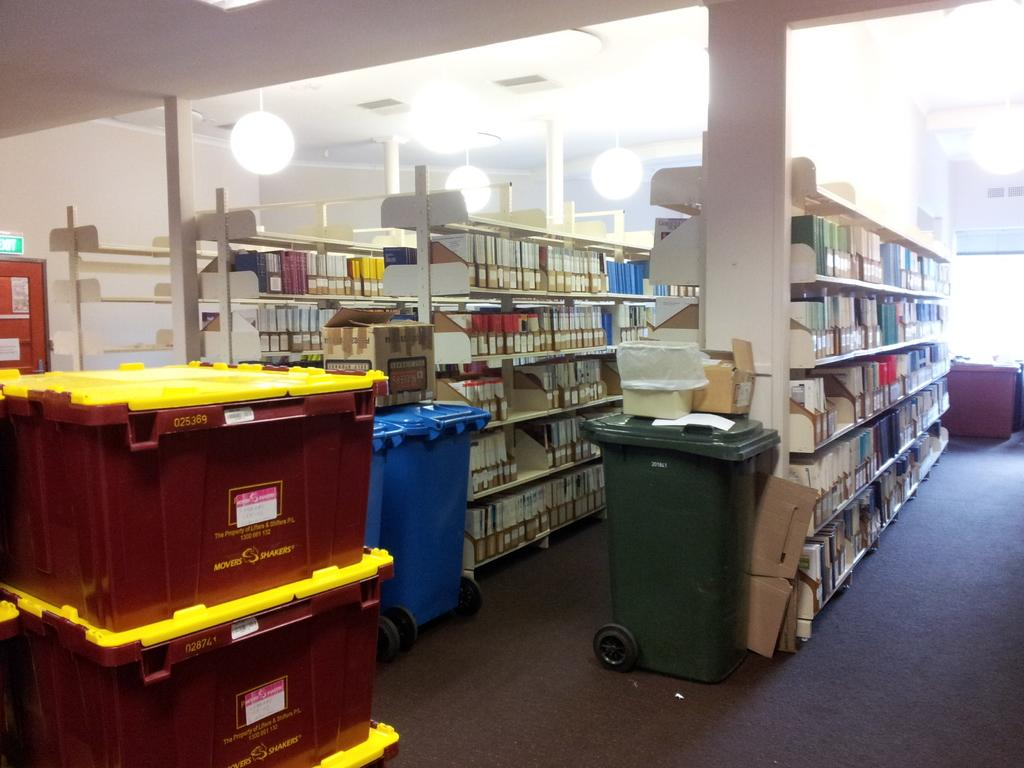<image>
Render a clear and concise summary of the photo. bins with stuff in them from movers and shakers 